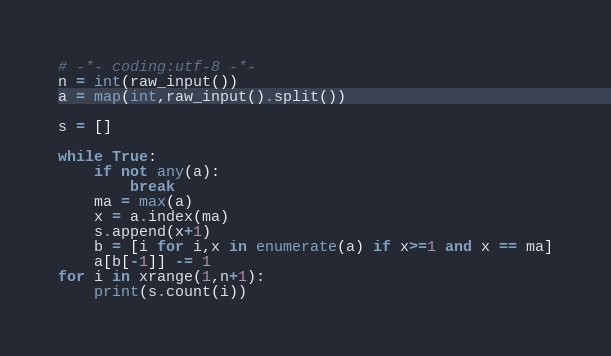Convert code to text. <code><loc_0><loc_0><loc_500><loc_500><_Python_># -*- coding:utf-8 -*-
n = int(raw_input())
a = map(int,raw_input().split())

s = []

while True:
    if not any(a):
        break
    ma = max(a)
    x = a.index(ma)
    s.append(x+1)
    b = [i for i,x in enumerate(a) if x>=1 and x == ma]
    a[b[-1]] -= 1
for i in xrange(1,n+1):
    print(s.count(i))
</code> 